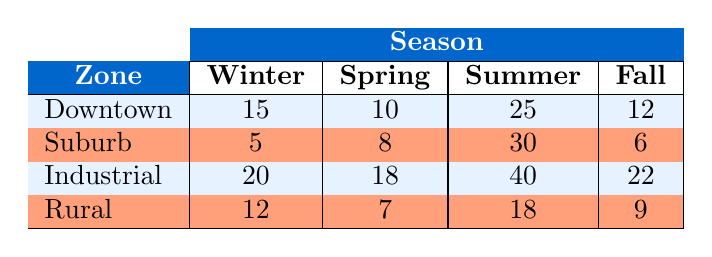What is the voltage fluctuation in the Suburb zone during Winter? The table shows three pieces of data for the Suburb zone, and the value in the Winter column is 5.
Answer: 5 Which zone has the highest voltage fluctuations in Summer? The highest value in the Summer column of the table is found in the Industrial zone with 40 fluctuations.
Answer: Industrial What is the total number of voltage fluctuations recorded for the Downtown zone across all seasons? To find the total for Downtown, sum the values for all seasons: 15 (Winter) + 10 (Spring) + 25 (Summer) + 12 (Fall) = 62.
Answer: 62 Is the voltage fluctuation higher in Winter for the Rural zone compared to the Suburb zone? The Rural zone has 12 fluctuations in Winter, while the Suburb zone has 5, so yes, Rural has a higher fluctuation.
Answer: Yes What is the average number of voltage fluctuations for the Industrial zone across all seasons? To calculate the average, sum up the fluctuations: 20 (Winter) + 18 (Spring) + 40 (Summer) + 22 (Fall) = 100. There are 4 seasons, so the average is 100/4 = 25.
Answer: 25 In which season does the Suburb zone show its lowest voltage fluctuations? Looking at the Suburb row, the lowest value is 5 during Winter compared to other seasons (8 in Spring, 30 in Summer, and 6 in Fall).
Answer: Winter How does the voltage fluctuation in Summer compare between Downtown and Industrial zones? For Summer, Downtown has 25 fluctuations, while Industrial has 40. Since 40 is greater than 25, Industrial has higher fluctuations in Summer.
Answer: Industrial Are there any zones where voltage fluctuations in Spring and Fall are equal? By reviewing the Spring and Fall values for all zones, we find no matching values; they differ for each zone, thus the answer is no.
Answer: No What is the combined voltage fluctuation for the Rural zone in Spring and Fall? To find the combined fluctuations for Rural in Spring and Fall, add 7 (Spring) + 9 (Fall) = 16.
Answer: 16 